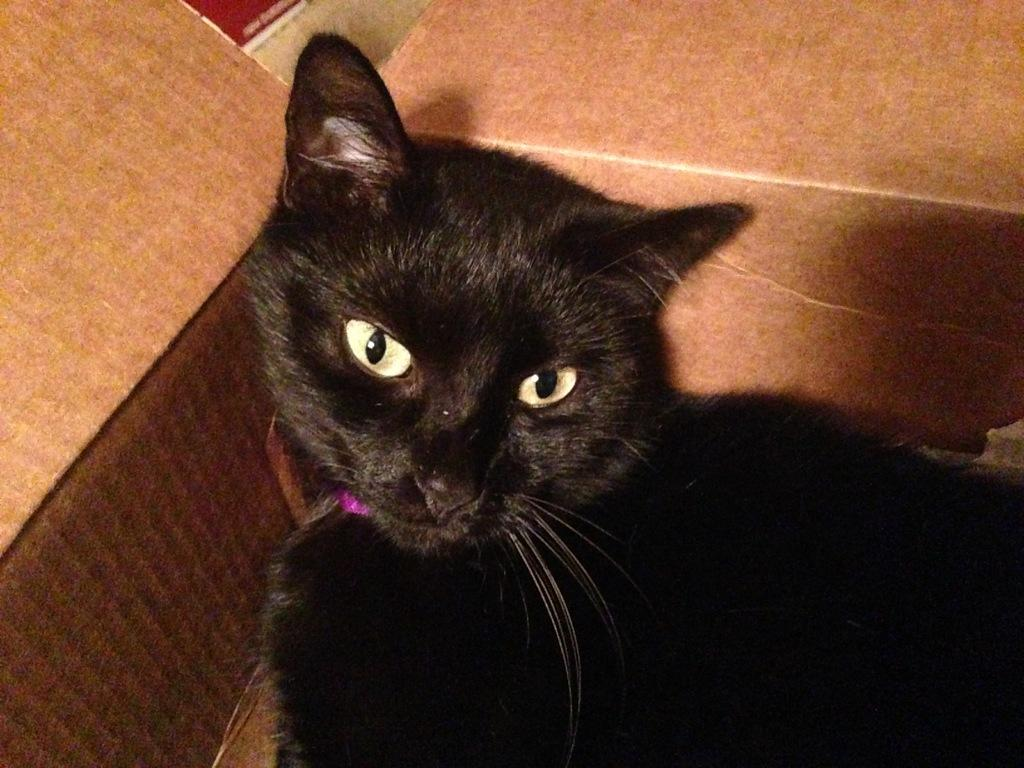What type of animal is in the image? There is a black cat in the image. Where is the black cat located? The black cat is in a cardboard box. Can you describe the positioning of the cat and box in the image? The cat and box are in the foreground of the image. What type of committee is responsible for the condition of the sack in the image? There is no committee or sack present in the image; it features a black cat in a cardboard box. 